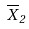<formula> <loc_0><loc_0><loc_500><loc_500>\overline { X } _ { 2 }</formula> 